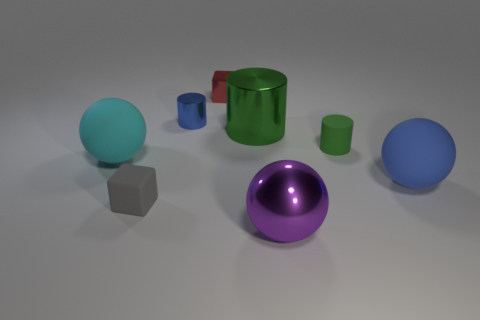Add 2 big matte balls. How many objects exist? 10 Subtract all blocks. How many objects are left? 6 Subtract all red metal spheres. Subtract all large purple objects. How many objects are left? 7 Add 5 large green metallic objects. How many large green metallic objects are left? 6 Add 4 small red things. How many small red things exist? 5 Subtract 0 green blocks. How many objects are left? 8 